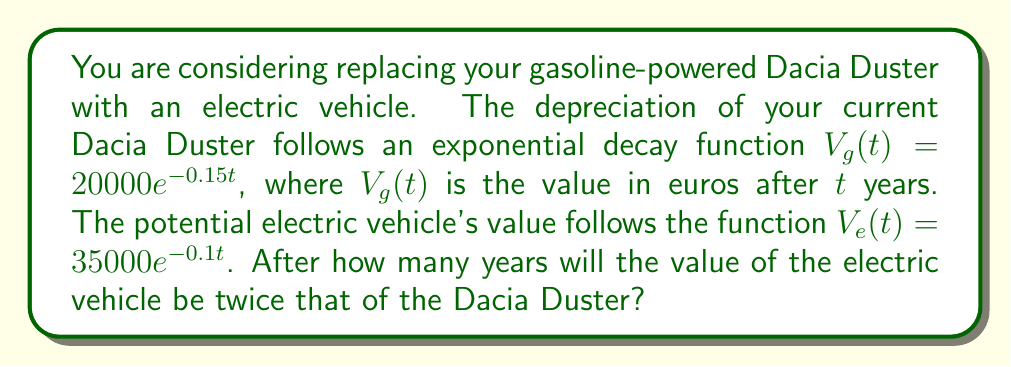Can you answer this question? To solve this problem, we need to set up an equation where the value of the electric vehicle is twice that of the Dacia Duster:

$$V_e(t) = 2V_g(t)$$

Substituting the given functions:

$$35000e^{-0.1t} = 2(20000e^{-0.15t})$$

Simplifying the right side:

$$35000e^{-0.1t} = 40000e^{-0.15t}$$

Dividing both sides by 35000:

$$e^{-0.1t} = \frac{40000}{35000}e^{-0.15t}$$

Taking the natural logarithm of both sides:

$$-0.1t = \ln(\frac{40000}{35000}) - 0.15t$$

Simplifying:

$$-0.1t = \ln(\frac{8}{7}) - 0.15t$$

$$0.05t = \ln(\frac{8}{7})$$

Solving for t:

$$t = \frac{\ln(\frac{8}{7})}{0.05}$$

Using a calculator or computer:

$$t \approx 2.75 \text{ years}$$
Answer: The value of the electric vehicle will be twice that of the Dacia Duster after approximately 2.75 years. 